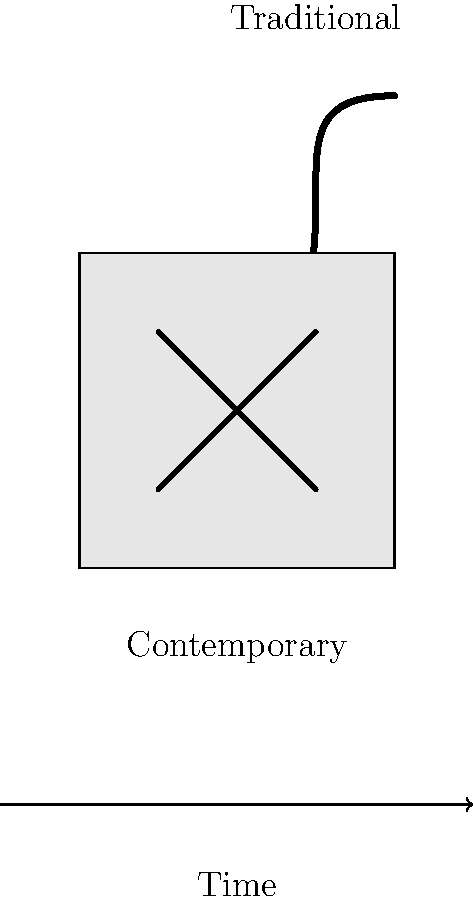How has Maori art evolved from traditional to contemporary styles, and what does this evolution reflect about Maori culture and identity in modern New Zealand society? 1. Traditional Maori art:
   - Characterized by curvilinear designs like the koru (spiral)
   - Deeply rooted in nature and spiritual beliefs
   - Used in carving, tattooing (ta moko), and weaving

2. Contemporary Maori art:
   - Incorporates traditional elements but with modern interpretations
   - Often blends geometric shapes with traditional motifs
   - Utilizes a wider range of media and techniques

3. Evolution reflects:
   - Adaptation to changing societal contexts
   - Preservation of cultural identity while embracing modernity
   - Increased dialogue between Maori and Pakeha (European) artistic traditions

4. Cultural significance:
   - Art as a means of cultural revitalization and assertion
   - Representation of Maori perspectives in mainstream New Zealand culture
   - Bridge between traditional knowledge and contemporary issues

5. Social media impact:
   - Increased visibility and accessibility of Maori art
   - Platform for young Maori artists to showcase their work
   - Facilitates global appreciation and discussion of Maori artistic heritage

This evolution demonstrates the resilience and adaptability of Maori culture, as well as its ongoing importance in shaping New Zealand's national identity.
Answer: Maori art has evolved from nature-inspired, spiritually significant designs to contemporary styles blending traditional motifs with modern techniques, reflecting cultural adaptation and preservation in modern New Zealand society. 